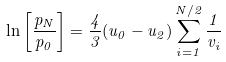<formula> <loc_0><loc_0><loc_500><loc_500>\ln \left [ \frac { p _ { N } } { p _ { 0 } } \right ] = \frac { 4 } { 3 } ( u _ { 0 } - u _ { 2 } ) \sum ^ { N / 2 } _ { i = 1 } \frac { 1 } { v _ { i } }</formula> 